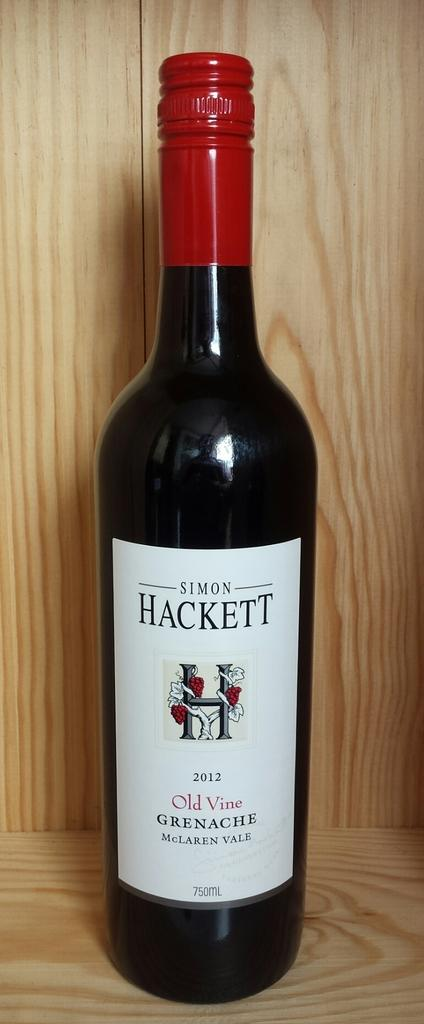<image>
Give a short and clear explanation of the subsequent image. A wine bottle with a label that says SIMON HACKETT. 